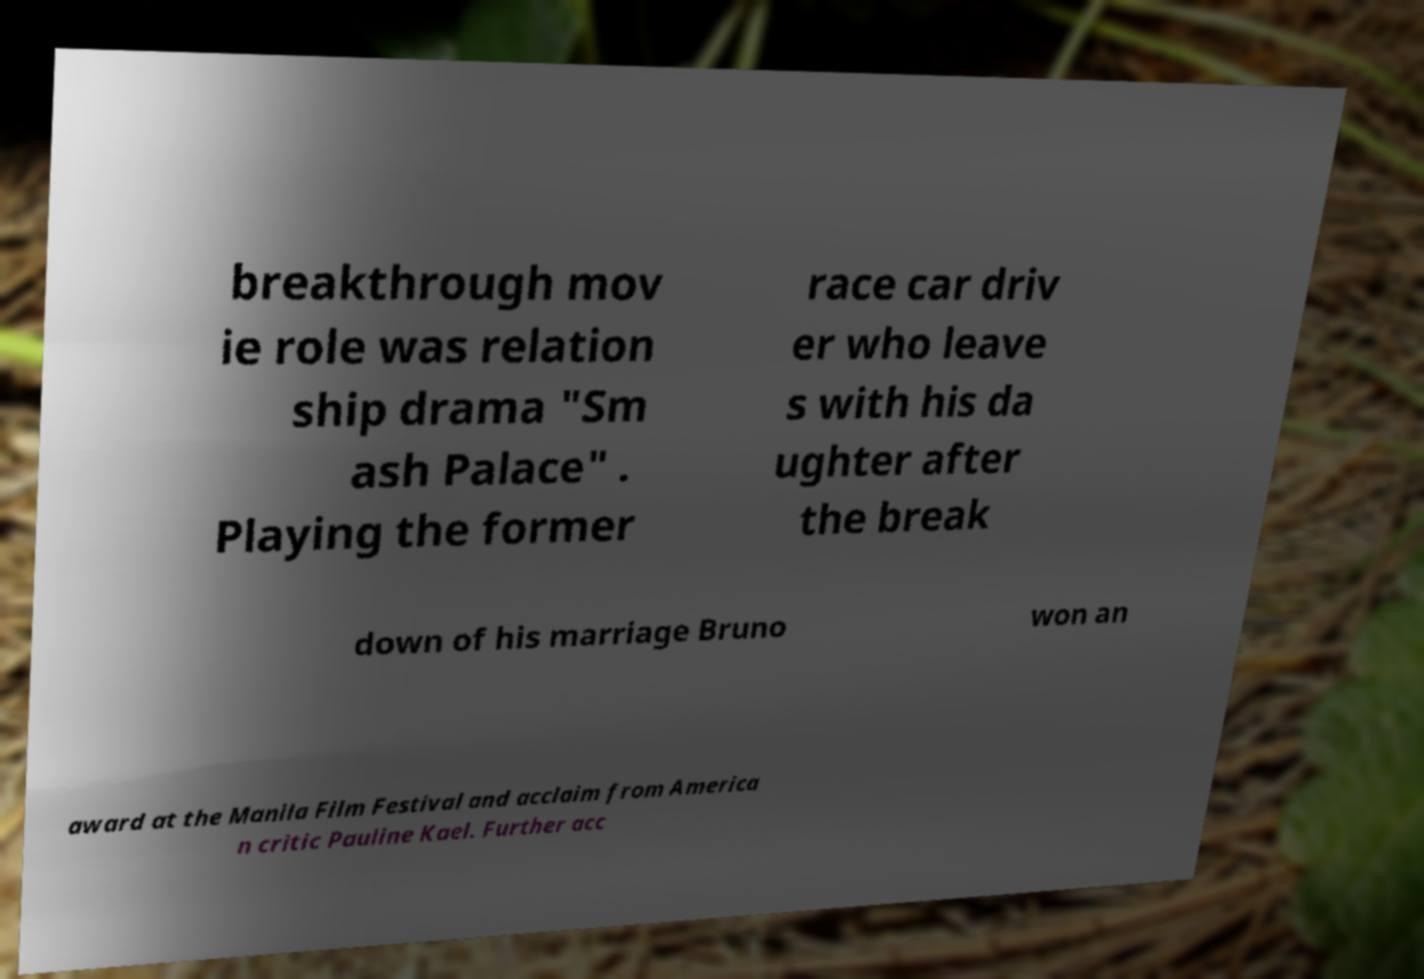Can you accurately transcribe the text from the provided image for me? breakthrough mov ie role was relation ship drama "Sm ash Palace" . Playing the former race car driv er who leave s with his da ughter after the break down of his marriage Bruno won an award at the Manila Film Festival and acclaim from America n critic Pauline Kael. Further acc 